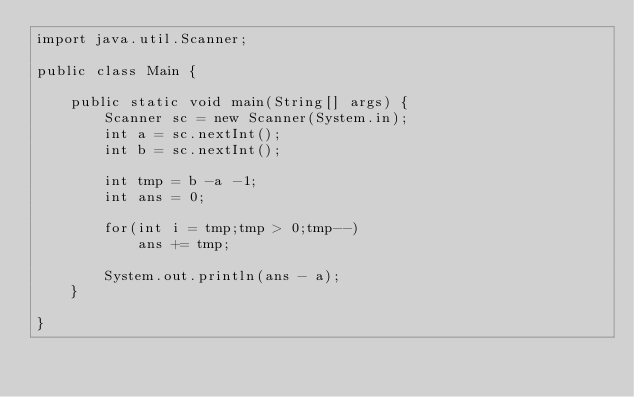Convert code to text. <code><loc_0><loc_0><loc_500><loc_500><_Java_>import java.util.Scanner;

public class Main {

	public static void main(String[] args) {
		Scanner sc = new Scanner(System.in);
		int a = sc.nextInt();
		int b = sc.nextInt();
		
		int tmp = b -a -1;
		int ans = 0;
		
		for(int i = tmp;tmp > 0;tmp--)
			ans += tmp;
		
		System.out.println(ans - a);
	}

}
</code> 